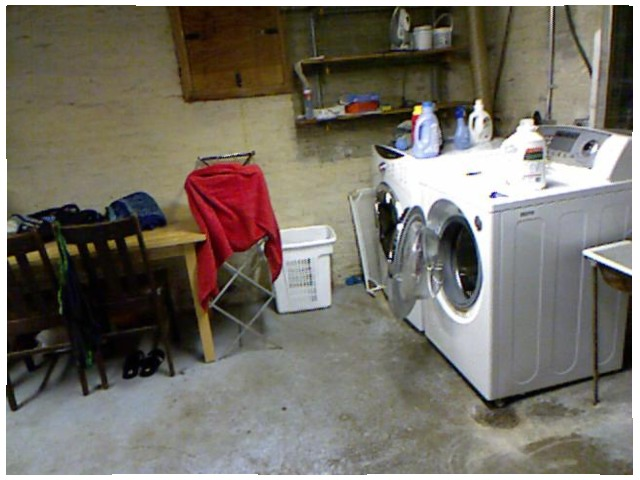<image>
Is there a chair under the slipper? Yes. The chair is positioned underneath the slipper, with the slipper above it in the vertical space. Is the washer in front of the dryer? No. The washer is not in front of the dryer. The spatial positioning shows a different relationship between these objects. Is there a door on the washing machine? Yes. Looking at the image, I can see the door is positioned on top of the washing machine, with the washing machine providing support. Where is the jeans in relation to the table? Is it on the table? Yes. Looking at the image, I can see the jeans is positioned on top of the table, with the table providing support. Is there a detergent to the right of the washing machine? No. The detergent is not to the right of the washing machine. The horizontal positioning shows a different relationship. Where is the washing machine in relation to the table? Is it to the right of the table? No. The washing machine is not to the right of the table. The horizontal positioning shows a different relationship. Where is the red towel in relation to the dryer? Is it in the dryer? No. The red towel is not contained within the dryer. These objects have a different spatial relationship. 